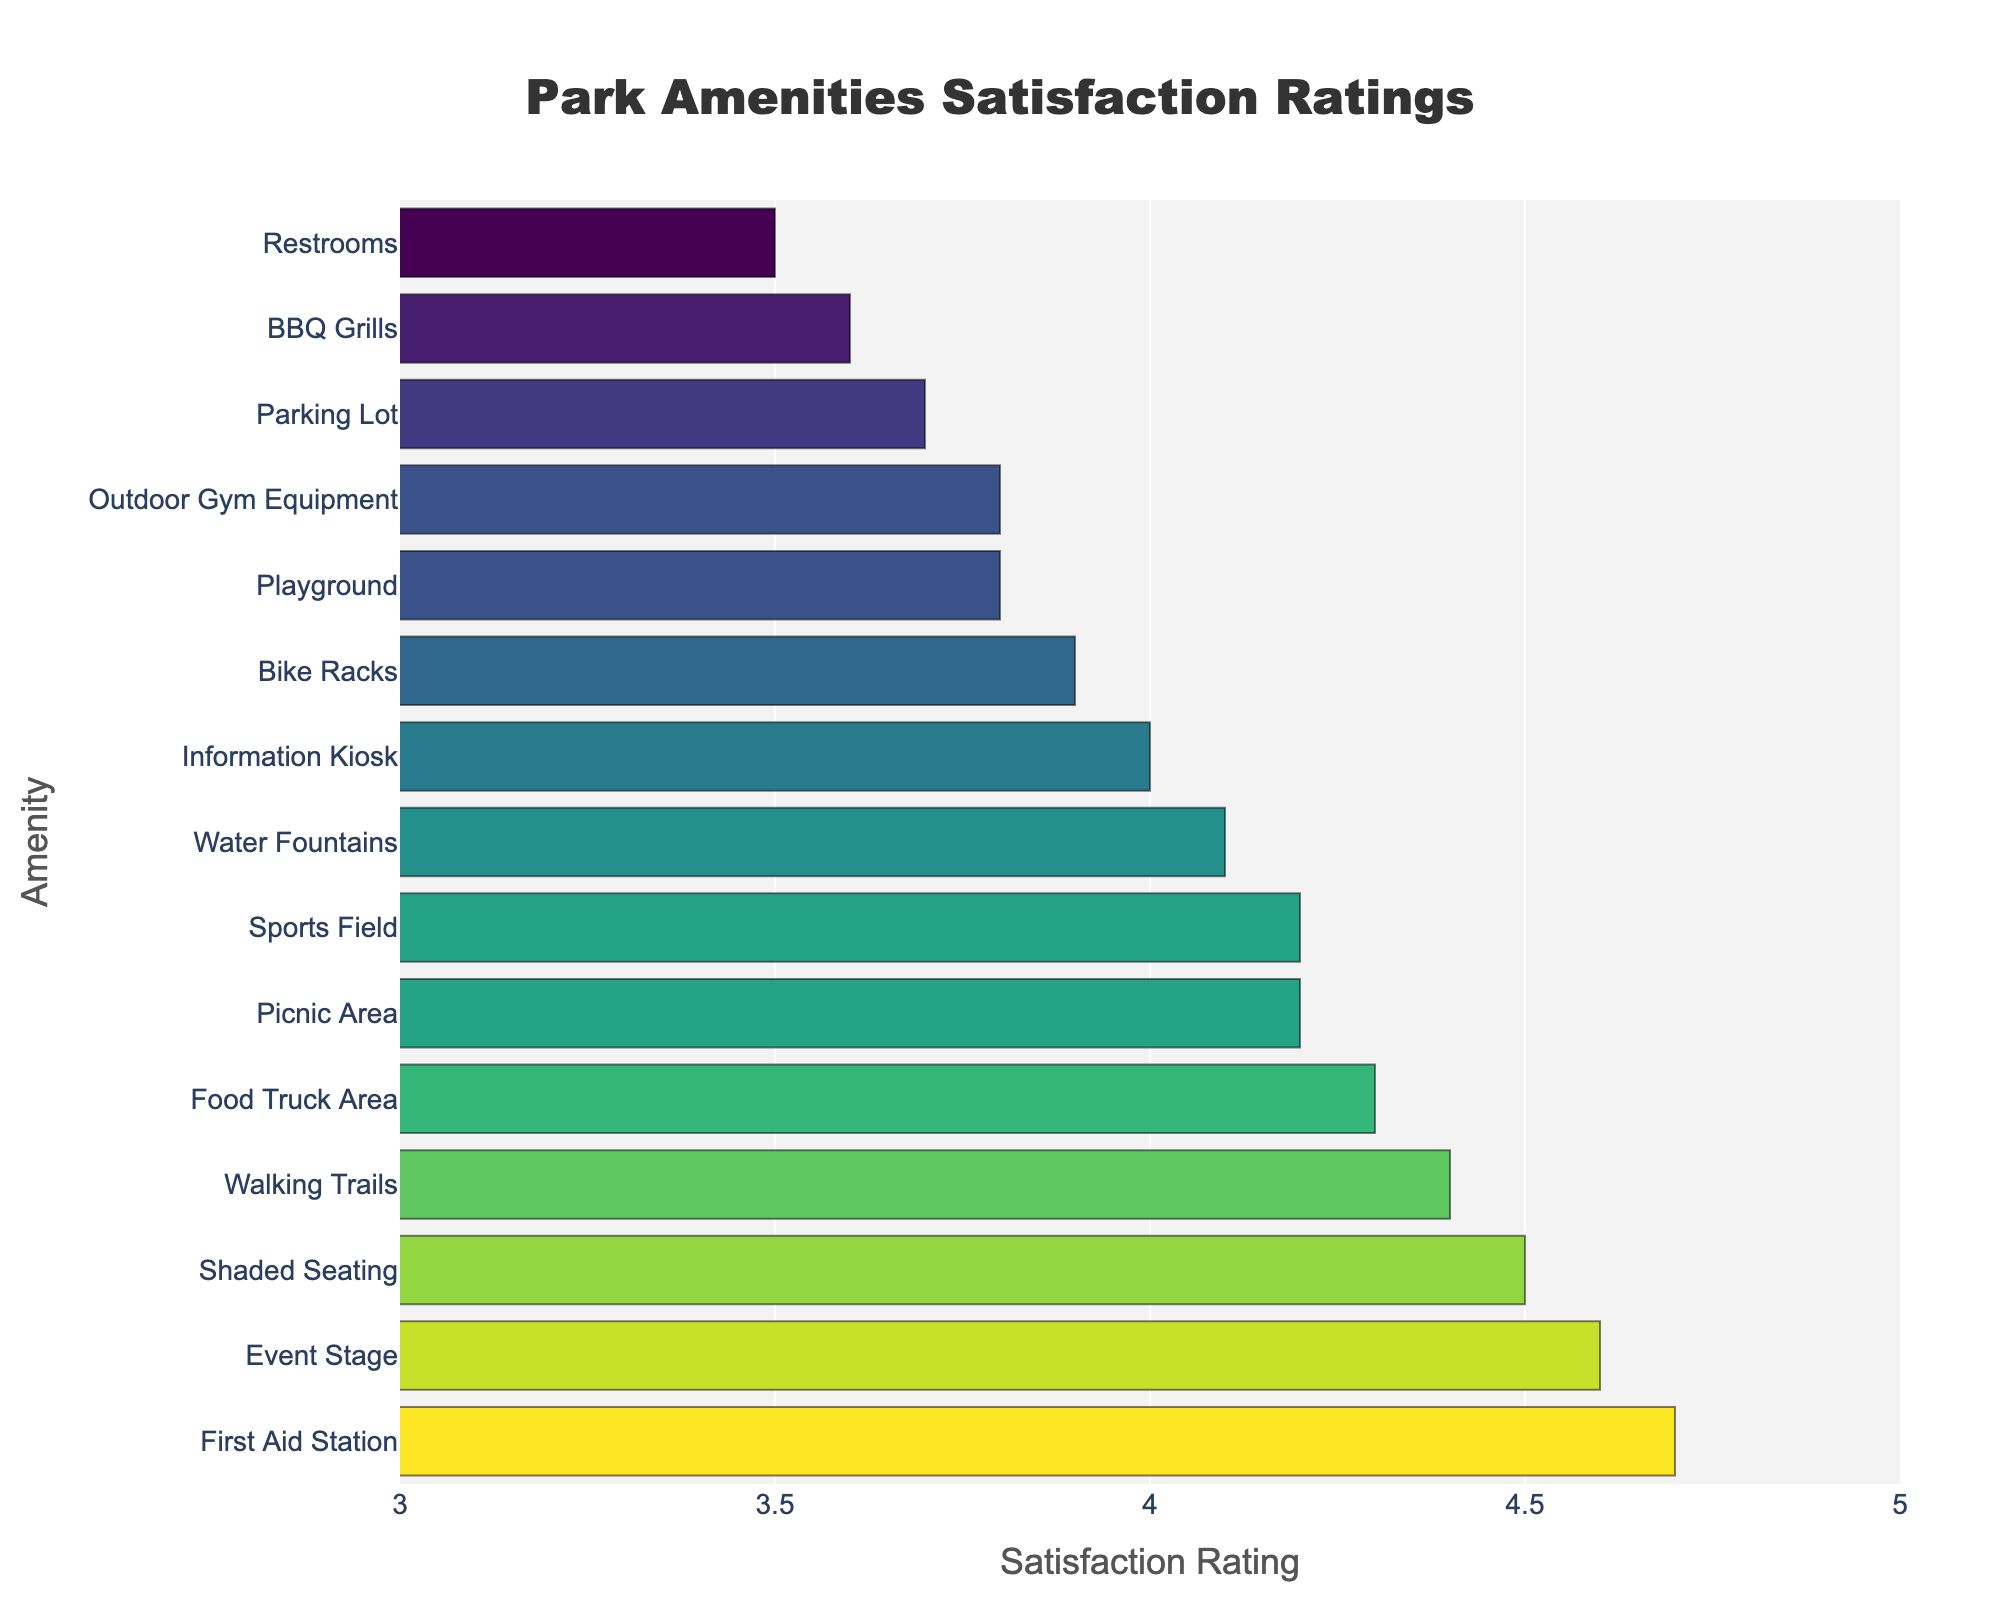Which amenity has the highest satisfaction rating? The bar for First Aid Station extends the farthest to the right with a rating of 4.7, indicating it has the highest satisfaction rating.
Answer: First Aid Station Which amenities have the same satisfaction rating? Both Picnic Area and Sports Field have bars that extend to the same length, showing a satisfaction rating of 4.2. Similarly, Playground and Outdoor Gym Equipment both have bars that extend to a rating of 3.8.
Answer: Picnic Area and Sports Field, Playground and Outdoor Gym Equipment How much higher is the satisfaction rating for the Event Stage compared to the Restrooms? The satisfaction rating for Event Stage is 4.6, and for Restrooms, it is 3.5. Subtracting these values gives 4.6 - 3.5 = 1.1.
Answer: 1.1 What is the average satisfaction rating for all amenities? Sum all the ratings: 4.2 + 3.8 + 3.5 + 4.1 + 4.5 + 4.3 + 4.7 + 3.9 + 4.0 + 4.4 + 3.7 + 4.6 + 3.6 + 4.2 + 3.8. This totals 61.3. There are 15 amenities, so the average is 61.3/15 = 4.09.
Answer: 4.09 Are there more amenities with a rating above 4.0 or below 4.0? Count the amenities with ratings above 4.0 (First Aid Station, Event Stage, Shaded Seating, Walking Trails, Food Truck Area, Water Fountains, Picnic Area, Sports Field, Information Kiosk) and those below 4.0 (Restrooms, Parking Lot, BBQ Grills, Playground, Outdoor Gym Equipment, Bike Racks). There are 9 above and 6 below.
Answer: Above 4.0 What percentage of amenities have a satisfaction rating of 4.0 or higher? Count the number of amenities with ratings of 4.0 or higher (9) and divide by the total number of amenities (15). Multiply by 100 to get the percentage: (9/15) * 100 = 60%.
Answer: 60% Which amenity has the closest satisfaction rating to the average rating of all amenities? The average rating of all amenities is 4.09. The Information Kiosk has a rating of 4.0, which is closest to 4.09 among the other ratings.
Answer: Information Kiosk Which has a higher satisfaction rating, the BBQ Grills or the Information Kiosk? Compare the bars for BBQ Grills (3.6) and Information Kiosk (4.0). The Information Kiosk’s bar extends further to the right, indicating a higher rating.
Answer: Information Kiosk 